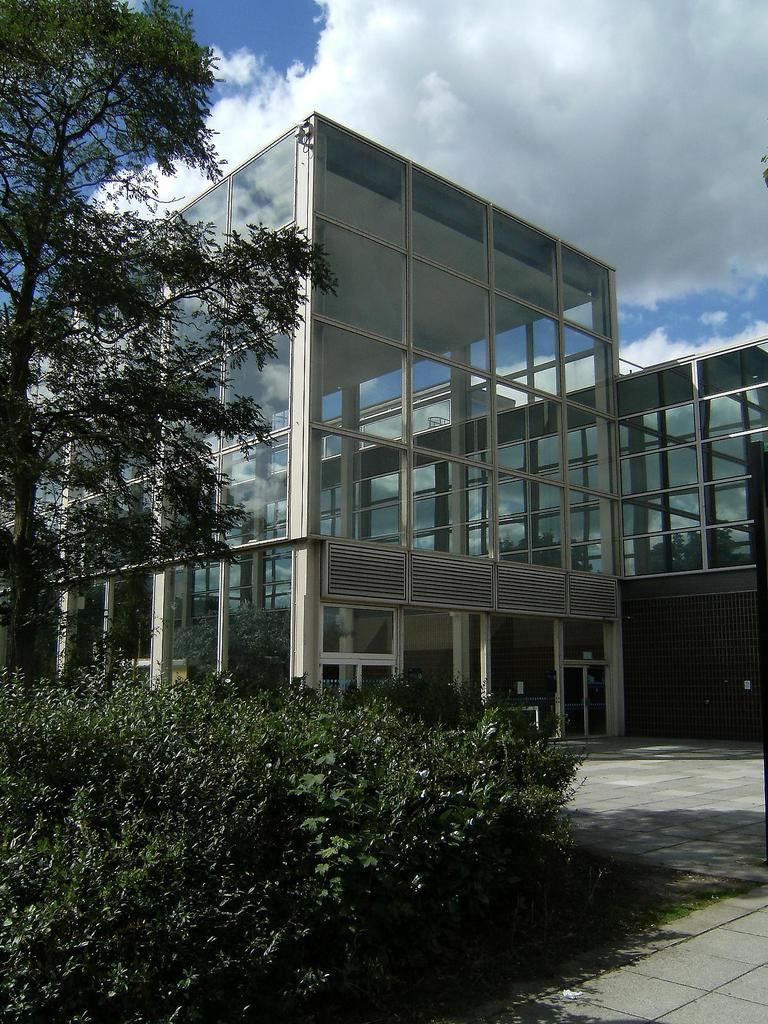What type of structures can be seen in the image? There are buildings in the image. Where is the tree located in the image? The tree is on the left side of the image. What type of vegetation is present in the image? There are plants in the image. What is visible at the top of the image? The sky is visible at the top of the image. What can be seen in the sky in the image? Clouds are present in the sky. What type of sweater is draped over the roof of the building in the image? There is no sweater present in the image; it only features buildings, a tree, plants, and a sky with clouds. What type of home is depicted in the image? The image does not depict a specific home; it shows buildings, a tree, plants, and a sky with clouds. 